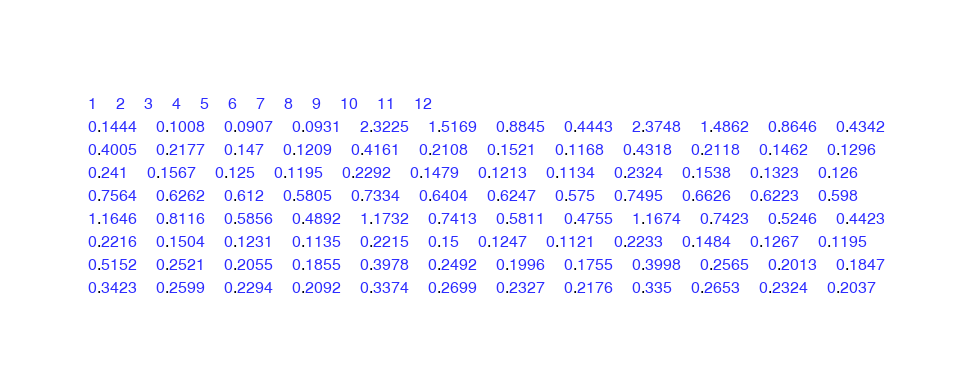Convert code to text. <code><loc_0><loc_0><loc_500><loc_500><_SQL_>1	2	3	4	5	6	7	8	9	10	11	12
0.1444	0.1008	0.0907	0.0931	2.3225	1.5169	0.8845	0.4443	2.3748	1.4862	0.8646	0.4342
0.4005	0.2177	0.147	0.1209	0.4161	0.2108	0.1521	0.1168	0.4318	0.2118	0.1462	0.1296
0.241	0.1567	0.125	0.1195	0.2292	0.1479	0.1213	0.1134	0.2324	0.1538	0.1323	0.126
0.7564	0.6262	0.612	0.5805	0.7334	0.6404	0.6247	0.575	0.7495	0.6626	0.6223	0.598
1.1646	0.8116	0.5856	0.4892	1.1732	0.7413	0.5811	0.4755	1.1674	0.7423	0.5246	0.4423
0.2216	0.1504	0.1231	0.1135	0.2215	0.15	0.1247	0.1121	0.2233	0.1484	0.1267	0.1195
0.5152	0.2521	0.2055	0.1855	0.3978	0.2492	0.1996	0.1755	0.3998	0.2565	0.2013	0.1847
0.3423	0.2599	0.2294	0.2092	0.3374	0.2699	0.2327	0.2176	0.335	0.2653	0.2324	0.2037
</code> 